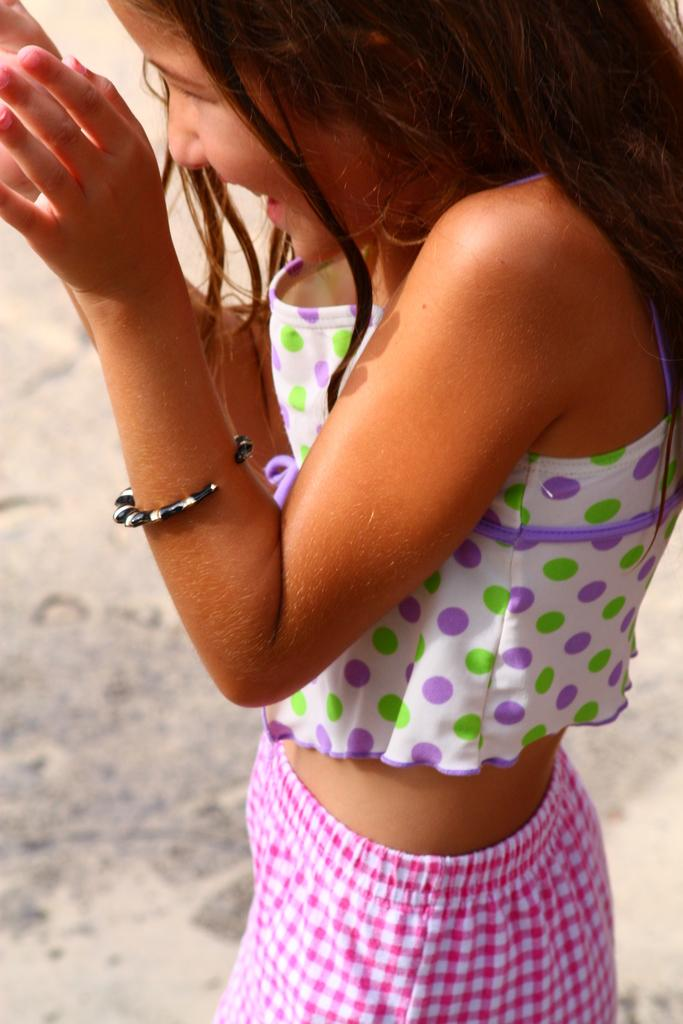Who is the main subject in the image? There is a girl in the image. What can be seen behind the girl in the image? The ground is visible behind the girl in the image. What type of lock is being used to secure the vegetable in the image? There is no lock or vegetable present in the image; it only features a girl and the ground behind her. 